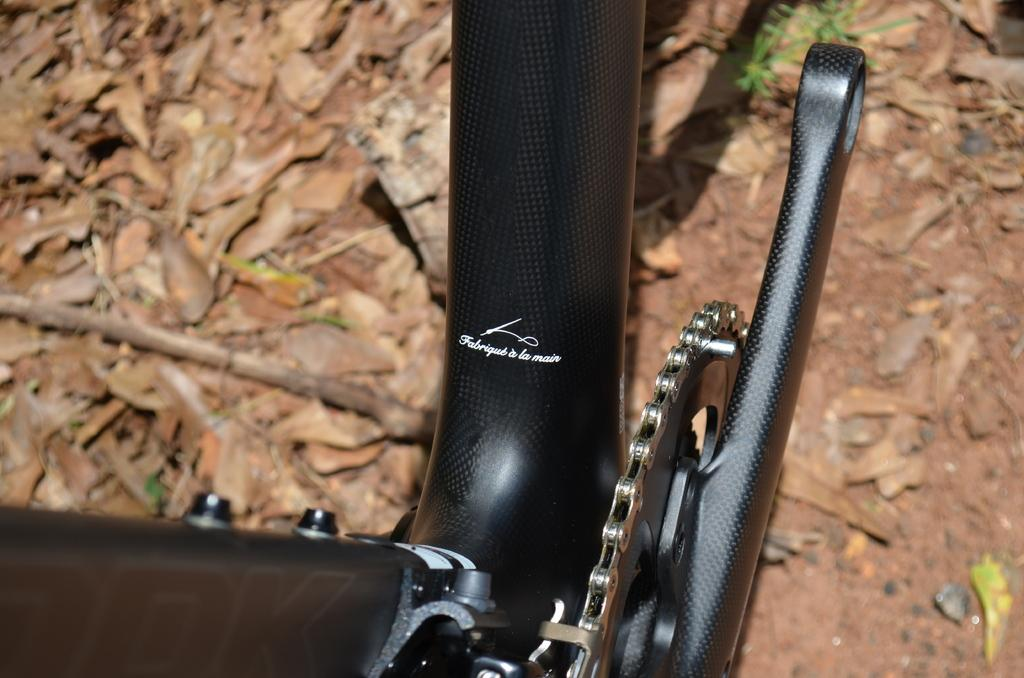What object is partially visible in the picture? There is a partial part of a bicycle in the picture. What type of natural debris can be seen on the ground? Dried leaves and twigs are visible on the ground. What unit of measurement is being used to describe the size of the key in the image? There is no key present in the image, so it is not possible to determine the unit of measurement being used. 